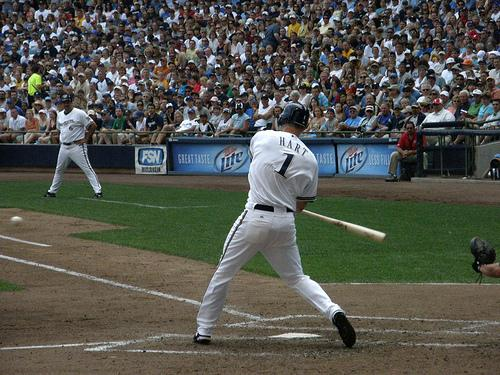According to the banner ad what kind of Lite beer tastes great?

Choices:
A) heineken
B) miller
C) corona
D) bud miller 